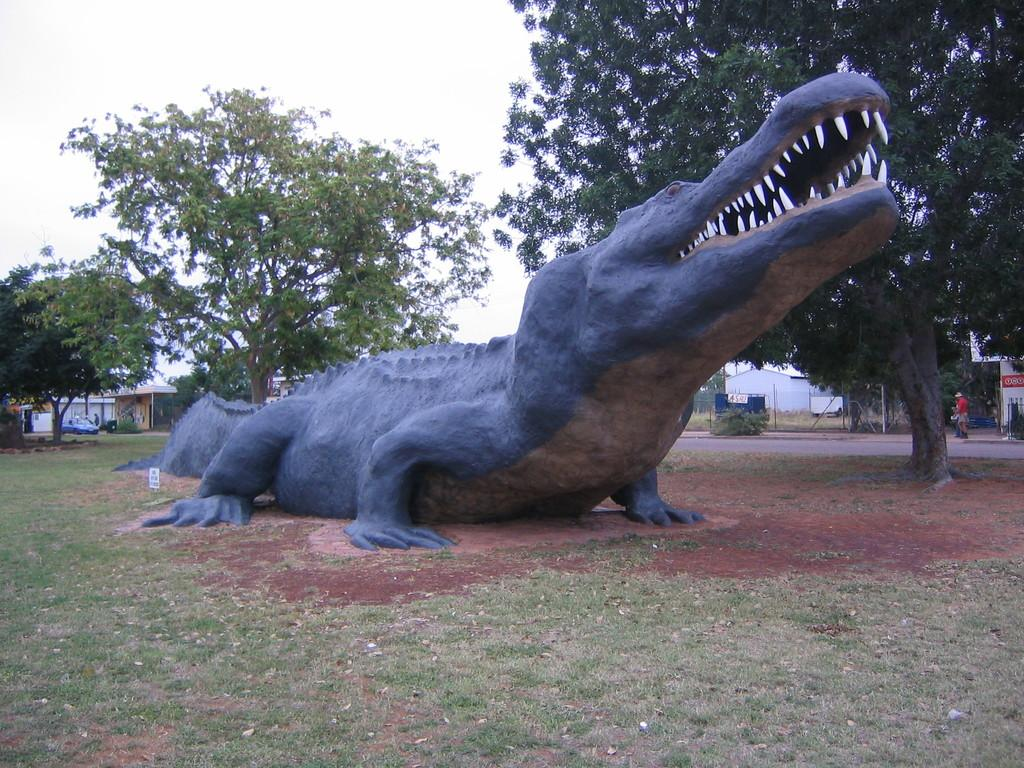What is the main subject of the image? There is a statue of a crocodile in the image. What can be seen on the ground near the statue? There is greenery on the ground beside the statue. What is visible in the background of the image? There are trees, persons, and buildings in the background of the image. How many pages of the book can be seen in the image? There is no book present in the image, so it is not possible to determine the number of pages. 